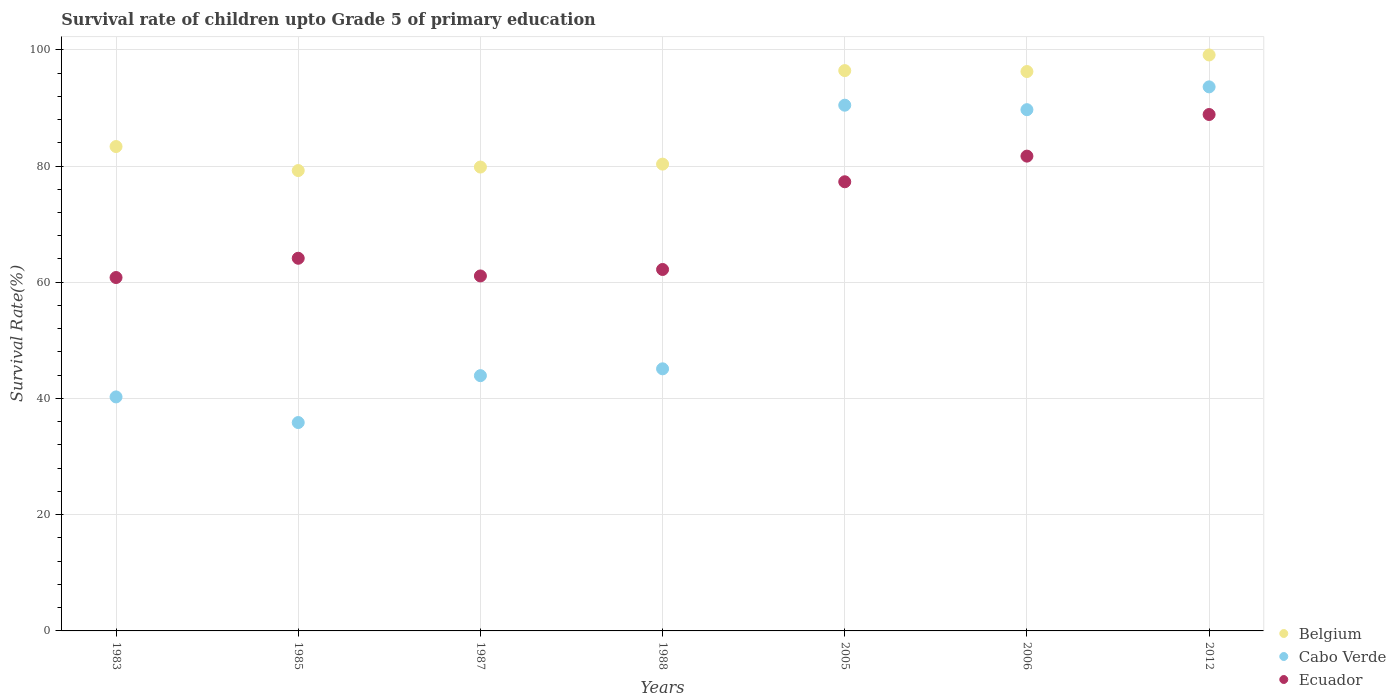Is the number of dotlines equal to the number of legend labels?
Keep it short and to the point. Yes. What is the survival rate of children in Cabo Verde in 1985?
Offer a very short reply. 35.86. Across all years, what is the maximum survival rate of children in Cabo Verde?
Provide a succinct answer. 93.62. Across all years, what is the minimum survival rate of children in Ecuador?
Your answer should be compact. 60.81. In which year was the survival rate of children in Belgium maximum?
Keep it short and to the point. 2012. In which year was the survival rate of children in Belgium minimum?
Your answer should be compact. 1985. What is the total survival rate of children in Belgium in the graph?
Provide a succinct answer. 614.5. What is the difference between the survival rate of children in Belgium in 1985 and that in 2005?
Offer a very short reply. -17.2. What is the difference between the survival rate of children in Cabo Verde in 2006 and the survival rate of children in Belgium in 2012?
Your answer should be compact. -9.42. What is the average survival rate of children in Ecuador per year?
Offer a very short reply. 70.87. In the year 2006, what is the difference between the survival rate of children in Belgium and survival rate of children in Cabo Verde?
Give a very brief answer. 6.57. In how many years, is the survival rate of children in Belgium greater than 8 %?
Make the answer very short. 7. What is the ratio of the survival rate of children in Ecuador in 1985 to that in 2006?
Offer a very short reply. 0.78. Is the survival rate of children in Belgium in 1987 less than that in 2012?
Provide a succinct answer. Yes. What is the difference between the highest and the second highest survival rate of children in Ecuador?
Keep it short and to the point. 7.16. What is the difference between the highest and the lowest survival rate of children in Cabo Verde?
Offer a very short reply. 57.76. Does the survival rate of children in Belgium monotonically increase over the years?
Provide a short and direct response. No. Is the survival rate of children in Ecuador strictly less than the survival rate of children in Belgium over the years?
Your answer should be compact. Yes. How many years are there in the graph?
Give a very brief answer. 7. Are the values on the major ticks of Y-axis written in scientific E-notation?
Your response must be concise. No. Does the graph contain any zero values?
Offer a terse response. No. How are the legend labels stacked?
Keep it short and to the point. Vertical. What is the title of the graph?
Offer a terse response. Survival rate of children upto Grade 5 of primary education. Does "Croatia" appear as one of the legend labels in the graph?
Your answer should be very brief. No. What is the label or title of the Y-axis?
Make the answer very short. Survival Rate(%). What is the Survival Rate(%) of Belgium in 1983?
Your answer should be compact. 83.35. What is the Survival Rate(%) in Cabo Verde in 1983?
Keep it short and to the point. 40.27. What is the Survival Rate(%) in Ecuador in 1983?
Offer a terse response. 60.81. What is the Survival Rate(%) in Belgium in 1985?
Keep it short and to the point. 79.22. What is the Survival Rate(%) of Cabo Verde in 1985?
Keep it short and to the point. 35.86. What is the Survival Rate(%) of Ecuador in 1985?
Keep it short and to the point. 64.13. What is the Survival Rate(%) of Belgium in 1987?
Keep it short and to the point. 79.82. What is the Survival Rate(%) of Cabo Verde in 1987?
Your response must be concise. 43.93. What is the Survival Rate(%) of Ecuador in 1987?
Your response must be concise. 61.08. What is the Survival Rate(%) of Belgium in 1988?
Provide a succinct answer. 80.32. What is the Survival Rate(%) of Cabo Verde in 1988?
Ensure brevity in your answer.  45.1. What is the Survival Rate(%) of Ecuador in 1988?
Keep it short and to the point. 62.2. What is the Survival Rate(%) in Belgium in 2005?
Your answer should be very brief. 96.42. What is the Survival Rate(%) in Cabo Verde in 2005?
Your response must be concise. 90.46. What is the Survival Rate(%) of Ecuador in 2005?
Provide a succinct answer. 77.29. What is the Survival Rate(%) in Belgium in 2006?
Your response must be concise. 96.26. What is the Survival Rate(%) in Cabo Verde in 2006?
Your response must be concise. 89.69. What is the Survival Rate(%) in Ecuador in 2006?
Your answer should be very brief. 81.7. What is the Survival Rate(%) in Belgium in 2012?
Provide a short and direct response. 99.11. What is the Survival Rate(%) of Cabo Verde in 2012?
Your response must be concise. 93.62. What is the Survival Rate(%) in Ecuador in 2012?
Offer a very short reply. 88.86. Across all years, what is the maximum Survival Rate(%) in Belgium?
Provide a short and direct response. 99.11. Across all years, what is the maximum Survival Rate(%) in Cabo Verde?
Provide a short and direct response. 93.62. Across all years, what is the maximum Survival Rate(%) of Ecuador?
Offer a very short reply. 88.86. Across all years, what is the minimum Survival Rate(%) of Belgium?
Ensure brevity in your answer.  79.22. Across all years, what is the minimum Survival Rate(%) in Cabo Verde?
Offer a terse response. 35.86. Across all years, what is the minimum Survival Rate(%) of Ecuador?
Keep it short and to the point. 60.81. What is the total Survival Rate(%) in Belgium in the graph?
Ensure brevity in your answer.  614.5. What is the total Survival Rate(%) in Cabo Verde in the graph?
Offer a terse response. 438.93. What is the total Survival Rate(%) of Ecuador in the graph?
Give a very brief answer. 496.07. What is the difference between the Survival Rate(%) of Belgium in 1983 and that in 1985?
Your answer should be very brief. 4.13. What is the difference between the Survival Rate(%) in Cabo Verde in 1983 and that in 1985?
Your answer should be very brief. 4.41. What is the difference between the Survival Rate(%) of Ecuador in 1983 and that in 1985?
Ensure brevity in your answer.  -3.31. What is the difference between the Survival Rate(%) in Belgium in 1983 and that in 1987?
Make the answer very short. 3.53. What is the difference between the Survival Rate(%) of Cabo Verde in 1983 and that in 1987?
Offer a terse response. -3.66. What is the difference between the Survival Rate(%) in Ecuador in 1983 and that in 1987?
Your answer should be compact. -0.27. What is the difference between the Survival Rate(%) of Belgium in 1983 and that in 1988?
Your answer should be very brief. 3.03. What is the difference between the Survival Rate(%) of Cabo Verde in 1983 and that in 1988?
Make the answer very short. -4.84. What is the difference between the Survival Rate(%) of Ecuador in 1983 and that in 1988?
Make the answer very short. -1.38. What is the difference between the Survival Rate(%) in Belgium in 1983 and that in 2005?
Provide a succinct answer. -13.07. What is the difference between the Survival Rate(%) in Cabo Verde in 1983 and that in 2005?
Provide a succinct answer. -50.2. What is the difference between the Survival Rate(%) of Ecuador in 1983 and that in 2005?
Provide a short and direct response. -16.48. What is the difference between the Survival Rate(%) in Belgium in 1983 and that in 2006?
Give a very brief answer. -12.91. What is the difference between the Survival Rate(%) in Cabo Verde in 1983 and that in 2006?
Ensure brevity in your answer.  -49.43. What is the difference between the Survival Rate(%) in Ecuador in 1983 and that in 2006?
Your response must be concise. -20.89. What is the difference between the Survival Rate(%) in Belgium in 1983 and that in 2012?
Make the answer very short. -15.76. What is the difference between the Survival Rate(%) in Cabo Verde in 1983 and that in 2012?
Your response must be concise. -53.35. What is the difference between the Survival Rate(%) of Ecuador in 1983 and that in 2012?
Give a very brief answer. -28.05. What is the difference between the Survival Rate(%) in Belgium in 1985 and that in 1987?
Provide a succinct answer. -0.6. What is the difference between the Survival Rate(%) of Cabo Verde in 1985 and that in 1987?
Give a very brief answer. -8.07. What is the difference between the Survival Rate(%) in Ecuador in 1985 and that in 1987?
Offer a very short reply. 3.04. What is the difference between the Survival Rate(%) of Belgium in 1985 and that in 1988?
Provide a succinct answer. -1.11. What is the difference between the Survival Rate(%) of Cabo Verde in 1985 and that in 1988?
Your response must be concise. -9.25. What is the difference between the Survival Rate(%) of Ecuador in 1985 and that in 1988?
Provide a short and direct response. 1.93. What is the difference between the Survival Rate(%) of Belgium in 1985 and that in 2005?
Ensure brevity in your answer.  -17.2. What is the difference between the Survival Rate(%) in Cabo Verde in 1985 and that in 2005?
Your response must be concise. -54.61. What is the difference between the Survival Rate(%) of Ecuador in 1985 and that in 2005?
Offer a terse response. -13.16. What is the difference between the Survival Rate(%) of Belgium in 1985 and that in 2006?
Offer a terse response. -17.04. What is the difference between the Survival Rate(%) in Cabo Verde in 1985 and that in 2006?
Give a very brief answer. -53.84. What is the difference between the Survival Rate(%) in Ecuador in 1985 and that in 2006?
Offer a terse response. -17.58. What is the difference between the Survival Rate(%) in Belgium in 1985 and that in 2012?
Keep it short and to the point. -19.89. What is the difference between the Survival Rate(%) of Cabo Verde in 1985 and that in 2012?
Keep it short and to the point. -57.76. What is the difference between the Survival Rate(%) in Ecuador in 1985 and that in 2012?
Your response must be concise. -24.74. What is the difference between the Survival Rate(%) of Belgium in 1987 and that in 1988?
Offer a terse response. -0.5. What is the difference between the Survival Rate(%) of Cabo Verde in 1987 and that in 1988?
Your response must be concise. -1.18. What is the difference between the Survival Rate(%) of Ecuador in 1987 and that in 1988?
Keep it short and to the point. -1.11. What is the difference between the Survival Rate(%) in Belgium in 1987 and that in 2005?
Make the answer very short. -16.6. What is the difference between the Survival Rate(%) of Cabo Verde in 1987 and that in 2005?
Your response must be concise. -46.54. What is the difference between the Survival Rate(%) in Ecuador in 1987 and that in 2005?
Your answer should be very brief. -16.21. What is the difference between the Survival Rate(%) of Belgium in 1987 and that in 2006?
Your answer should be compact. -16.44. What is the difference between the Survival Rate(%) in Cabo Verde in 1987 and that in 2006?
Offer a terse response. -45.77. What is the difference between the Survival Rate(%) of Ecuador in 1987 and that in 2006?
Your answer should be compact. -20.62. What is the difference between the Survival Rate(%) in Belgium in 1987 and that in 2012?
Give a very brief answer. -19.29. What is the difference between the Survival Rate(%) in Cabo Verde in 1987 and that in 2012?
Your answer should be very brief. -49.69. What is the difference between the Survival Rate(%) in Ecuador in 1987 and that in 2012?
Keep it short and to the point. -27.78. What is the difference between the Survival Rate(%) in Belgium in 1988 and that in 2005?
Your response must be concise. -16.09. What is the difference between the Survival Rate(%) of Cabo Verde in 1988 and that in 2005?
Keep it short and to the point. -45.36. What is the difference between the Survival Rate(%) of Ecuador in 1988 and that in 2005?
Your response must be concise. -15.09. What is the difference between the Survival Rate(%) in Belgium in 1988 and that in 2006?
Keep it short and to the point. -15.93. What is the difference between the Survival Rate(%) of Cabo Verde in 1988 and that in 2006?
Ensure brevity in your answer.  -44.59. What is the difference between the Survival Rate(%) of Ecuador in 1988 and that in 2006?
Keep it short and to the point. -19.51. What is the difference between the Survival Rate(%) of Belgium in 1988 and that in 2012?
Make the answer very short. -18.79. What is the difference between the Survival Rate(%) in Cabo Verde in 1988 and that in 2012?
Provide a short and direct response. -48.52. What is the difference between the Survival Rate(%) in Ecuador in 1988 and that in 2012?
Make the answer very short. -26.67. What is the difference between the Survival Rate(%) in Belgium in 2005 and that in 2006?
Give a very brief answer. 0.16. What is the difference between the Survival Rate(%) of Cabo Verde in 2005 and that in 2006?
Ensure brevity in your answer.  0.77. What is the difference between the Survival Rate(%) of Ecuador in 2005 and that in 2006?
Ensure brevity in your answer.  -4.41. What is the difference between the Survival Rate(%) in Belgium in 2005 and that in 2012?
Make the answer very short. -2.69. What is the difference between the Survival Rate(%) in Cabo Verde in 2005 and that in 2012?
Provide a succinct answer. -3.15. What is the difference between the Survival Rate(%) in Ecuador in 2005 and that in 2012?
Your answer should be very brief. -11.57. What is the difference between the Survival Rate(%) in Belgium in 2006 and that in 2012?
Provide a succinct answer. -2.85. What is the difference between the Survival Rate(%) of Cabo Verde in 2006 and that in 2012?
Give a very brief answer. -3.93. What is the difference between the Survival Rate(%) of Ecuador in 2006 and that in 2012?
Your response must be concise. -7.16. What is the difference between the Survival Rate(%) of Belgium in 1983 and the Survival Rate(%) of Cabo Verde in 1985?
Ensure brevity in your answer.  47.5. What is the difference between the Survival Rate(%) of Belgium in 1983 and the Survival Rate(%) of Ecuador in 1985?
Provide a succinct answer. 19.23. What is the difference between the Survival Rate(%) of Cabo Verde in 1983 and the Survival Rate(%) of Ecuador in 1985?
Ensure brevity in your answer.  -23.86. What is the difference between the Survival Rate(%) of Belgium in 1983 and the Survival Rate(%) of Cabo Verde in 1987?
Give a very brief answer. 39.43. What is the difference between the Survival Rate(%) in Belgium in 1983 and the Survival Rate(%) in Ecuador in 1987?
Your response must be concise. 22.27. What is the difference between the Survival Rate(%) in Cabo Verde in 1983 and the Survival Rate(%) in Ecuador in 1987?
Ensure brevity in your answer.  -20.82. What is the difference between the Survival Rate(%) in Belgium in 1983 and the Survival Rate(%) in Cabo Verde in 1988?
Ensure brevity in your answer.  38.25. What is the difference between the Survival Rate(%) in Belgium in 1983 and the Survival Rate(%) in Ecuador in 1988?
Your response must be concise. 21.16. What is the difference between the Survival Rate(%) in Cabo Verde in 1983 and the Survival Rate(%) in Ecuador in 1988?
Provide a succinct answer. -21.93. What is the difference between the Survival Rate(%) of Belgium in 1983 and the Survival Rate(%) of Cabo Verde in 2005?
Give a very brief answer. -7.11. What is the difference between the Survival Rate(%) in Belgium in 1983 and the Survival Rate(%) in Ecuador in 2005?
Give a very brief answer. 6.06. What is the difference between the Survival Rate(%) in Cabo Verde in 1983 and the Survival Rate(%) in Ecuador in 2005?
Keep it short and to the point. -37.02. What is the difference between the Survival Rate(%) in Belgium in 1983 and the Survival Rate(%) in Cabo Verde in 2006?
Offer a terse response. -6.34. What is the difference between the Survival Rate(%) of Belgium in 1983 and the Survival Rate(%) of Ecuador in 2006?
Keep it short and to the point. 1.65. What is the difference between the Survival Rate(%) in Cabo Verde in 1983 and the Survival Rate(%) in Ecuador in 2006?
Make the answer very short. -41.43. What is the difference between the Survival Rate(%) in Belgium in 1983 and the Survival Rate(%) in Cabo Verde in 2012?
Offer a terse response. -10.27. What is the difference between the Survival Rate(%) in Belgium in 1983 and the Survival Rate(%) in Ecuador in 2012?
Keep it short and to the point. -5.51. What is the difference between the Survival Rate(%) in Cabo Verde in 1983 and the Survival Rate(%) in Ecuador in 2012?
Make the answer very short. -48.6. What is the difference between the Survival Rate(%) of Belgium in 1985 and the Survival Rate(%) of Cabo Verde in 1987?
Provide a succinct answer. 35.29. What is the difference between the Survival Rate(%) of Belgium in 1985 and the Survival Rate(%) of Ecuador in 1987?
Your answer should be compact. 18.14. What is the difference between the Survival Rate(%) of Cabo Verde in 1985 and the Survival Rate(%) of Ecuador in 1987?
Your answer should be very brief. -25.23. What is the difference between the Survival Rate(%) of Belgium in 1985 and the Survival Rate(%) of Cabo Verde in 1988?
Offer a very short reply. 34.12. What is the difference between the Survival Rate(%) of Belgium in 1985 and the Survival Rate(%) of Ecuador in 1988?
Your answer should be very brief. 17.02. What is the difference between the Survival Rate(%) of Cabo Verde in 1985 and the Survival Rate(%) of Ecuador in 1988?
Provide a short and direct response. -26.34. What is the difference between the Survival Rate(%) of Belgium in 1985 and the Survival Rate(%) of Cabo Verde in 2005?
Your answer should be compact. -11.25. What is the difference between the Survival Rate(%) in Belgium in 1985 and the Survival Rate(%) in Ecuador in 2005?
Keep it short and to the point. 1.93. What is the difference between the Survival Rate(%) in Cabo Verde in 1985 and the Survival Rate(%) in Ecuador in 2005?
Keep it short and to the point. -41.43. What is the difference between the Survival Rate(%) in Belgium in 1985 and the Survival Rate(%) in Cabo Verde in 2006?
Ensure brevity in your answer.  -10.48. What is the difference between the Survival Rate(%) of Belgium in 1985 and the Survival Rate(%) of Ecuador in 2006?
Make the answer very short. -2.48. What is the difference between the Survival Rate(%) in Cabo Verde in 1985 and the Survival Rate(%) in Ecuador in 2006?
Provide a succinct answer. -45.84. What is the difference between the Survival Rate(%) of Belgium in 1985 and the Survival Rate(%) of Cabo Verde in 2012?
Your answer should be very brief. -14.4. What is the difference between the Survival Rate(%) of Belgium in 1985 and the Survival Rate(%) of Ecuador in 2012?
Your answer should be compact. -9.65. What is the difference between the Survival Rate(%) in Cabo Verde in 1985 and the Survival Rate(%) in Ecuador in 2012?
Ensure brevity in your answer.  -53.01. What is the difference between the Survival Rate(%) in Belgium in 1987 and the Survival Rate(%) in Cabo Verde in 1988?
Provide a short and direct response. 34.72. What is the difference between the Survival Rate(%) in Belgium in 1987 and the Survival Rate(%) in Ecuador in 1988?
Offer a very short reply. 17.63. What is the difference between the Survival Rate(%) in Cabo Verde in 1987 and the Survival Rate(%) in Ecuador in 1988?
Offer a very short reply. -18.27. What is the difference between the Survival Rate(%) of Belgium in 1987 and the Survival Rate(%) of Cabo Verde in 2005?
Your answer should be very brief. -10.64. What is the difference between the Survival Rate(%) of Belgium in 1987 and the Survival Rate(%) of Ecuador in 2005?
Your response must be concise. 2.53. What is the difference between the Survival Rate(%) of Cabo Verde in 1987 and the Survival Rate(%) of Ecuador in 2005?
Offer a terse response. -33.36. What is the difference between the Survival Rate(%) in Belgium in 1987 and the Survival Rate(%) in Cabo Verde in 2006?
Provide a short and direct response. -9.87. What is the difference between the Survival Rate(%) of Belgium in 1987 and the Survival Rate(%) of Ecuador in 2006?
Make the answer very short. -1.88. What is the difference between the Survival Rate(%) of Cabo Verde in 1987 and the Survival Rate(%) of Ecuador in 2006?
Give a very brief answer. -37.78. What is the difference between the Survival Rate(%) in Belgium in 1987 and the Survival Rate(%) in Cabo Verde in 2012?
Your answer should be compact. -13.8. What is the difference between the Survival Rate(%) in Belgium in 1987 and the Survival Rate(%) in Ecuador in 2012?
Give a very brief answer. -9.04. What is the difference between the Survival Rate(%) in Cabo Verde in 1987 and the Survival Rate(%) in Ecuador in 2012?
Your answer should be compact. -44.94. What is the difference between the Survival Rate(%) of Belgium in 1988 and the Survival Rate(%) of Cabo Verde in 2005?
Give a very brief answer. -10.14. What is the difference between the Survival Rate(%) of Belgium in 1988 and the Survival Rate(%) of Ecuador in 2005?
Offer a very short reply. 3.04. What is the difference between the Survival Rate(%) in Cabo Verde in 1988 and the Survival Rate(%) in Ecuador in 2005?
Your response must be concise. -32.19. What is the difference between the Survival Rate(%) in Belgium in 1988 and the Survival Rate(%) in Cabo Verde in 2006?
Offer a terse response. -9.37. What is the difference between the Survival Rate(%) of Belgium in 1988 and the Survival Rate(%) of Ecuador in 2006?
Your answer should be compact. -1.38. What is the difference between the Survival Rate(%) in Cabo Verde in 1988 and the Survival Rate(%) in Ecuador in 2006?
Offer a very short reply. -36.6. What is the difference between the Survival Rate(%) in Belgium in 1988 and the Survival Rate(%) in Cabo Verde in 2012?
Keep it short and to the point. -13.29. What is the difference between the Survival Rate(%) of Belgium in 1988 and the Survival Rate(%) of Ecuador in 2012?
Keep it short and to the point. -8.54. What is the difference between the Survival Rate(%) in Cabo Verde in 1988 and the Survival Rate(%) in Ecuador in 2012?
Provide a short and direct response. -43.76. What is the difference between the Survival Rate(%) of Belgium in 2005 and the Survival Rate(%) of Cabo Verde in 2006?
Ensure brevity in your answer.  6.72. What is the difference between the Survival Rate(%) in Belgium in 2005 and the Survival Rate(%) in Ecuador in 2006?
Offer a very short reply. 14.72. What is the difference between the Survival Rate(%) in Cabo Verde in 2005 and the Survival Rate(%) in Ecuador in 2006?
Ensure brevity in your answer.  8.76. What is the difference between the Survival Rate(%) in Belgium in 2005 and the Survival Rate(%) in Cabo Verde in 2012?
Offer a very short reply. 2.8. What is the difference between the Survival Rate(%) of Belgium in 2005 and the Survival Rate(%) of Ecuador in 2012?
Your answer should be very brief. 7.55. What is the difference between the Survival Rate(%) in Cabo Verde in 2005 and the Survival Rate(%) in Ecuador in 2012?
Keep it short and to the point. 1.6. What is the difference between the Survival Rate(%) of Belgium in 2006 and the Survival Rate(%) of Cabo Verde in 2012?
Make the answer very short. 2.64. What is the difference between the Survival Rate(%) in Belgium in 2006 and the Survival Rate(%) in Ecuador in 2012?
Keep it short and to the point. 7.4. What is the difference between the Survival Rate(%) in Cabo Verde in 2006 and the Survival Rate(%) in Ecuador in 2012?
Your response must be concise. 0.83. What is the average Survival Rate(%) of Belgium per year?
Your answer should be very brief. 87.79. What is the average Survival Rate(%) of Cabo Verde per year?
Make the answer very short. 62.7. What is the average Survival Rate(%) of Ecuador per year?
Your answer should be compact. 70.87. In the year 1983, what is the difference between the Survival Rate(%) in Belgium and Survival Rate(%) in Cabo Verde?
Make the answer very short. 43.09. In the year 1983, what is the difference between the Survival Rate(%) of Belgium and Survival Rate(%) of Ecuador?
Your answer should be compact. 22.54. In the year 1983, what is the difference between the Survival Rate(%) in Cabo Verde and Survival Rate(%) in Ecuador?
Ensure brevity in your answer.  -20.54. In the year 1985, what is the difference between the Survival Rate(%) in Belgium and Survival Rate(%) in Cabo Verde?
Your answer should be very brief. 43.36. In the year 1985, what is the difference between the Survival Rate(%) of Belgium and Survival Rate(%) of Ecuador?
Keep it short and to the point. 15.09. In the year 1985, what is the difference between the Survival Rate(%) in Cabo Verde and Survival Rate(%) in Ecuador?
Your response must be concise. -28.27. In the year 1987, what is the difference between the Survival Rate(%) in Belgium and Survival Rate(%) in Cabo Verde?
Offer a very short reply. 35.9. In the year 1987, what is the difference between the Survival Rate(%) in Belgium and Survival Rate(%) in Ecuador?
Your answer should be compact. 18.74. In the year 1987, what is the difference between the Survival Rate(%) of Cabo Verde and Survival Rate(%) of Ecuador?
Keep it short and to the point. -17.16. In the year 1988, what is the difference between the Survival Rate(%) in Belgium and Survival Rate(%) in Cabo Verde?
Offer a very short reply. 35.22. In the year 1988, what is the difference between the Survival Rate(%) in Belgium and Survival Rate(%) in Ecuador?
Your response must be concise. 18.13. In the year 1988, what is the difference between the Survival Rate(%) of Cabo Verde and Survival Rate(%) of Ecuador?
Offer a terse response. -17.09. In the year 2005, what is the difference between the Survival Rate(%) in Belgium and Survival Rate(%) in Cabo Verde?
Give a very brief answer. 5.95. In the year 2005, what is the difference between the Survival Rate(%) of Belgium and Survival Rate(%) of Ecuador?
Provide a short and direct response. 19.13. In the year 2005, what is the difference between the Survival Rate(%) of Cabo Verde and Survival Rate(%) of Ecuador?
Provide a succinct answer. 13.18. In the year 2006, what is the difference between the Survival Rate(%) in Belgium and Survival Rate(%) in Cabo Verde?
Provide a short and direct response. 6.57. In the year 2006, what is the difference between the Survival Rate(%) of Belgium and Survival Rate(%) of Ecuador?
Your answer should be very brief. 14.56. In the year 2006, what is the difference between the Survival Rate(%) in Cabo Verde and Survival Rate(%) in Ecuador?
Keep it short and to the point. 7.99. In the year 2012, what is the difference between the Survival Rate(%) of Belgium and Survival Rate(%) of Cabo Verde?
Offer a very short reply. 5.49. In the year 2012, what is the difference between the Survival Rate(%) of Belgium and Survival Rate(%) of Ecuador?
Offer a terse response. 10.25. In the year 2012, what is the difference between the Survival Rate(%) in Cabo Verde and Survival Rate(%) in Ecuador?
Your answer should be very brief. 4.76. What is the ratio of the Survival Rate(%) of Belgium in 1983 to that in 1985?
Your answer should be very brief. 1.05. What is the ratio of the Survival Rate(%) of Cabo Verde in 1983 to that in 1985?
Your answer should be very brief. 1.12. What is the ratio of the Survival Rate(%) in Ecuador in 1983 to that in 1985?
Your response must be concise. 0.95. What is the ratio of the Survival Rate(%) in Belgium in 1983 to that in 1987?
Offer a very short reply. 1.04. What is the ratio of the Survival Rate(%) in Cabo Verde in 1983 to that in 1987?
Make the answer very short. 0.92. What is the ratio of the Survival Rate(%) of Belgium in 1983 to that in 1988?
Make the answer very short. 1.04. What is the ratio of the Survival Rate(%) in Cabo Verde in 1983 to that in 1988?
Offer a very short reply. 0.89. What is the ratio of the Survival Rate(%) in Ecuador in 1983 to that in 1988?
Offer a very short reply. 0.98. What is the ratio of the Survival Rate(%) in Belgium in 1983 to that in 2005?
Give a very brief answer. 0.86. What is the ratio of the Survival Rate(%) in Cabo Verde in 1983 to that in 2005?
Give a very brief answer. 0.45. What is the ratio of the Survival Rate(%) of Ecuador in 1983 to that in 2005?
Your answer should be very brief. 0.79. What is the ratio of the Survival Rate(%) in Belgium in 1983 to that in 2006?
Ensure brevity in your answer.  0.87. What is the ratio of the Survival Rate(%) in Cabo Verde in 1983 to that in 2006?
Make the answer very short. 0.45. What is the ratio of the Survival Rate(%) of Ecuador in 1983 to that in 2006?
Offer a very short reply. 0.74. What is the ratio of the Survival Rate(%) of Belgium in 1983 to that in 2012?
Provide a short and direct response. 0.84. What is the ratio of the Survival Rate(%) of Cabo Verde in 1983 to that in 2012?
Ensure brevity in your answer.  0.43. What is the ratio of the Survival Rate(%) in Ecuador in 1983 to that in 2012?
Keep it short and to the point. 0.68. What is the ratio of the Survival Rate(%) in Belgium in 1985 to that in 1987?
Give a very brief answer. 0.99. What is the ratio of the Survival Rate(%) of Cabo Verde in 1985 to that in 1987?
Offer a very short reply. 0.82. What is the ratio of the Survival Rate(%) of Ecuador in 1985 to that in 1987?
Keep it short and to the point. 1.05. What is the ratio of the Survival Rate(%) in Belgium in 1985 to that in 1988?
Your answer should be very brief. 0.99. What is the ratio of the Survival Rate(%) of Cabo Verde in 1985 to that in 1988?
Make the answer very short. 0.8. What is the ratio of the Survival Rate(%) of Ecuador in 1985 to that in 1988?
Your answer should be compact. 1.03. What is the ratio of the Survival Rate(%) in Belgium in 1985 to that in 2005?
Offer a very short reply. 0.82. What is the ratio of the Survival Rate(%) of Cabo Verde in 1985 to that in 2005?
Your answer should be compact. 0.4. What is the ratio of the Survival Rate(%) in Ecuador in 1985 to that in 2005?
Provide a short and direct response. 0.83. What is the ratio of the Survival Rate(%) of Belgium in 1985 to that in 2006?
Your answer should be compact. 0.82. What is the ratio of the Survival Rate(%) in Cabo Verde in 1985 to that in 2006?
Give a very brief answer. 0.4. What is the ratio of the Survival Rate(%) of Ecuador in 1985 to that in 2006?
Your answer should be compact. 0.78. What is the ratio of the Survival Rate(%) in Belgium in 1985 to that in 2012?
Give a very brief answer. 0.8. What is the ratio of the Survival Rate(%) in Cabo Verde in 1985 to that in 2012?
Make the answer very short. 0.38. What is the ratio of the Survival Rate(%) in Ecuador in 1985 to that in 2012?
Your answer should be compact. 0.72. What is the ratio of the Survival Rate(%) of Belgium in 1987 to that in 1988?
Your answer should be compact. 0.99. What is the ratio of the Survival Rate(%) in Cabo Verde in 1987 to that in 1988?
Give a very brief answer. 0.97. What is the ratio of the Survival Rate(%) of Ecuador in 1987 to that in 1988?
Offer a very short reply. 0.98. What is the ratio of the Survival Rate(%) of Belgium in 1987 to that in 2005?
Your response must be concise. 0.83. What is the ratio of the Survival Rate(%) in Cabo Verde in 1987 to that in 2005?
Offer a very short reply. 0.49. What is the ratio of the Survival Rate(%) in Ecuador in 1987 to that in 2005?
Your answer should be very brief. 0.79. What is the ratio of the Survival Rate(%) in Belgium in 1987 to that in 2006?
Give a very brief answer. 0.83. What is the ratio of the Survival Rate(%) in Cabo Verde in 1987 to that in 2006?
Your answer should be compact. 0.49. What is the ratio of the Survival Rate(%) of Ecuador in 1987 to that in 2006?
Make the answer very short. 0.75. What is the ratio of the Survival Rate(%) of Belgium in 1987 to that in 2012?
Provide a succinct answer. 0.81. What is the ratio of the Survival Rate(%) in Cabo Verde in 1987 to that in 2012?
Offer a terse response. 0.47. What is the ratio of the Survival Rate(%) of Ecuador in 1987 to that in 2012?
Your answer should be compact. 0.69. What is the ratio of the Survival Rate(%) of Belgium in 1988 to that in 2005?
Provide a short and direct response. 0.83. What is the ratio of the Survival Rate(%) of Cabo Verde in 1988 to that in 2005?
Make the answer very short. 0.5. What is the ratio of the Survival Rate(%) in Ecuador in 1988 to that in 2005?
Ensure brevity in your answer.  0.8. What is the ratio of the Survival Rate(%) of Belgium in 1988 to that in 2006?
Offer a very short reply. 0.83. What is the ratio of the Survival Rate(%) of Cabo Verde in 1988 to that in 2006?
Keep it short and to the point. 0.5. What is the ratio of the Survival Rate(%) of Ecuador in 1988 to that in 2006?
Provide a succinct answer. 0.76. What is the ratio of the Survival Rate(%) of Belgium in 1988 to that in 2012?
Offer a very short reply. 0.81. What is the ratio of the Survival Rate(%) of Cabo Verde in 1988 to that in 2012?
Make the answer very short. 0.48. What is the ratio of the Survival Rate(%) in Ecuador in 1988 to that in 2012?
Offer a terse response. 0.7. What is the ratio of the Survival Rate(%) of Belgium in 2005 to that in 2006?
Offer a terse response. 1. What is the ratio of the Survival Rate(%) of Cabo Verde in 2005 to that in 2006?
Your answer should be very brief. 1.01. What is the ratio of the Survival Rate(%) in Ecuador in 2005 to that in 2006?
Provide a succinct answer. 0.95. What is the ratio of the Survival Rate(%) in Belgium in 2005 to that in 2012?
Offer a terse response. 0.97. What is the ratio of the Survival Rate(%) in Cabo Verde in 2005 to that in 2012?
Give a very brief answer. 0.97. What is the ratio of the Survival Rate(%) of Ecuador in 2005 to that in 2012?
Your response must be concise. 0.87. What is the ratio of the Survival Rate(%) of Belgium in 2006 to that in 2012?
Make the answer very short. 0.97. What is the ratio of the Survival Rate(%) of Cabo Verde in 2006 to that in 2012?
Keep it short and to the point. 0.96. What is the ratio of the Survival Rate(%) of Ecuador in 2006 to that in 2012?
Keep it short and to the point. 0.92. What is the difference between the highest and the second highest Survival Rate(%) in Belgium?
Your response must be concise. 2.69. What is the difference between the highest and the second highest Survival Rate(%) in Cabo Verde?
Offer a terse response. 3.15. What is the difference between the highest and the second highest Survival Rate(%) of Ecuador?
Ensure brevity in your answer.  7.16. What is the difference between the highest and the lowest Survival Rate(%) of Belgium?
Offer a terse response. 19.89. What is the difference between the highest and the lowest Survival Rate(%) of Cabo Verde?
Ensure brevity in your answer.  57.76. What is the difference between the highest and the lowest Survival Rate(%) in Ecuador?
Your response must be concise. 28.05. 